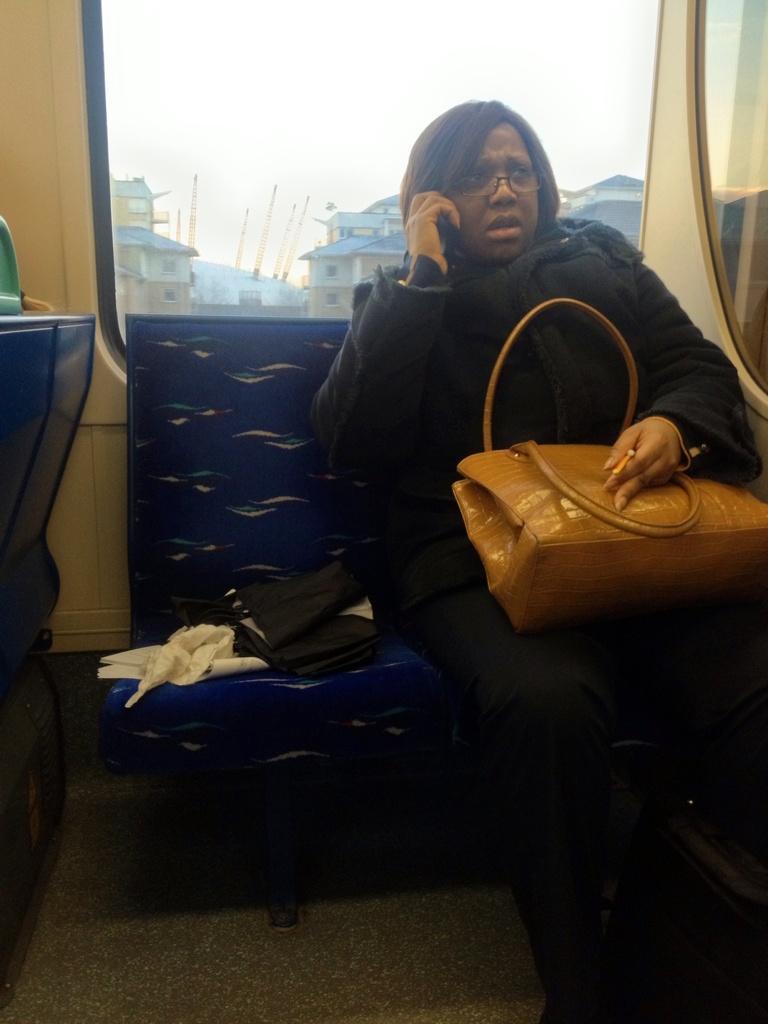In one or two sentences, can you explain what this image depicts? This picture is clicked inside a vehicle. There is a woman sitting on a seat. She is holding a mobile phone in her right hand and hand bag in her left hand. There is another bag beside her on the seat. Behind her there is a glass window. Through the window houses, poles and sky can be seen. 